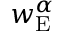Convert formula to latex. <formula><loc_0><loc_0><loc_500><loc_500>w _ { E } ^ { \alpha }</formula> 